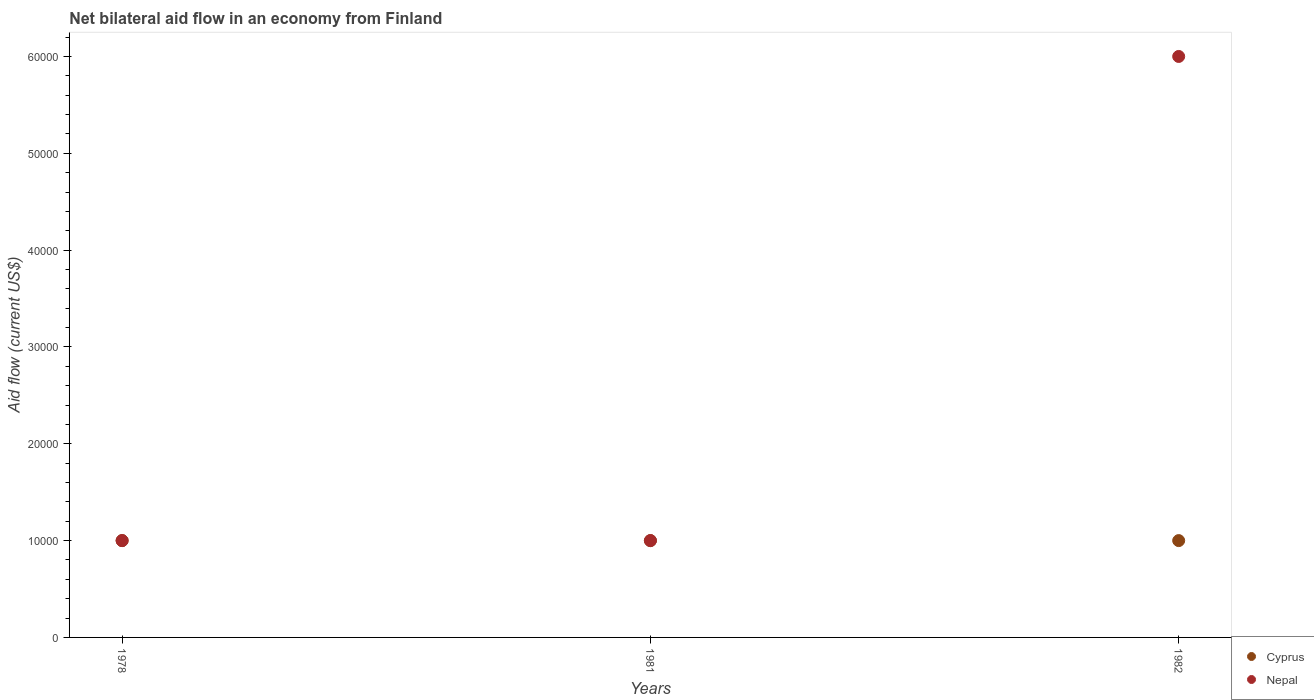How many different coloured dotlines are there?
Ensure brevity in your answer.  2. Is the number of dotlines equal to the number of legend labels?
Provide a succinct answer. Yes. In which year was the net bilateral aid flow in Nepal maximum?
Make the answer very short. 1982. In which year was the net bilateral aid flow in Cyprus minimum?
Provide a short and direct response. 1978. What is the difference between the net bilateral aid flow in Cyprus in 1978 and that in 1982?
Offer a terse response. 0. What is the difference between the net bilateral aid flow in Cyprus in 1978 and the net bilateral aid flow in Nepal in 1982?
Give a very brief answer. -5.00e+04. What is the average net bilateral aid flow in Nepal per year?
Your answer should be compact. 2.67e+04. In the year 1982, what is the difference between the net bilateral aid flow in Cyprus and net bilateral aid flow in Nepal?
Offer a terse response. -5.00e+04. In how many years, is the net bilateral aid flow in Nepal greater than 48000 US$?
Give a very brief answer. 1. What is the ratio of the net bilateral aid flow in Nepal in 1981 to that in 1982?
Your answer should be very brief. 0.17. Is the sum of the net bilateral aid flow in Cyprus in 1978 and 1982 greater than the maximum net bilateral aid flow in Nepal across all years?
Offer a very short reply. No. Does the net bilateral aid flow in Nepal monotonically increase over the years?
Make the answer very short. No. How many legend labels are there?
Your answer should be very brief. 2. How are the legend labels stacked?
Your response must be concise. Vertical. What is the title of the graph?
Your answer should be very brief. Net bilateral aid flow in an economy from Finland. What is the label or title of the X-axis?
Offer a terse response. Years. What is the label or title of the Y-axis?
Provide a short and direct response. Aid flow (current US$). What is the Aid flow (current US$) of Nepal in 1978?
Provide a succinct answer. 10000. What is the Aid flow (current US$) in Cyprus in 1981?
Offer a terse response. 10000. What is the Aid flow (current US$) of Nepal in 1981?
Your response must be concise. 10000. What is the Aid flow (current US$) of Cyprus in 1982?
Make the answer very short. 10000. What is the Aid flow (current US$) of Nepal in 1982?
Provide a succinct answer. 6.00e+04. Across all years, what is the maximum Aid flow (current US$) in Cyprus?
Give a very brief answer. 10000. Across all years, what is the minimum Aid flow (current US$) of Nepal?
Make the answer very short. 10000. What is the total Aid flow (current US$) in Cyprus in the graph?
Offer a terse response. 3.00e+04. What is the total Aid flow (current US$) of Nepal in the graph?
Your answer should be compact. 8.00e+04. What is the difference between the Aid flow (current US$) of Cyprus in 1978 and the Aid flow (current US$) of Nepal in 1981?
Provide a succinct answer. 0. What is the difference between the Aid flow (current US$) in Cyprus in 1981 and the Aid flow (current US$) in Nepal in 1982?
Offer a terse response. -5.00e+04. What is the average Aid flow (current US$) of Nepal per year?
Your answer should be very brief. 2.67e+04. In the year 1978, what is the difference between the Aid flow (current US$) in Cyprus and Aid flow (current US$) in Nepal?
Your answer should be compact. 0. In the year 1981, what is the difference between the Aid flow (current US$) in Cyprus and Aid flow (current US$) in Nepal?
Offer a terse response. 0. In the year 1982, what is the difference between the Aid flow (current US$) in Cyprus and Aid flow (current US$) in Nepal?
Ensure brevity in your answer.  -5.00e+04. What is the ratio of the Aid flow (current US$) in Nepal in 1978 to that in 1982?
Make the answer very short. 0.17. What is the difference between the highest and the second highest Aid flow (current US$) of Cyprus?
Offer a terse response. 0. What is the difference between the highest and the lowest Aid flow (current US$) in Cyprus?
Ensure brevity in your answer.  0. What is the difference between the highest and the lowest Aid flow (current US$) in Nepal?
Provide a short and direct response. 5.00e+04. 